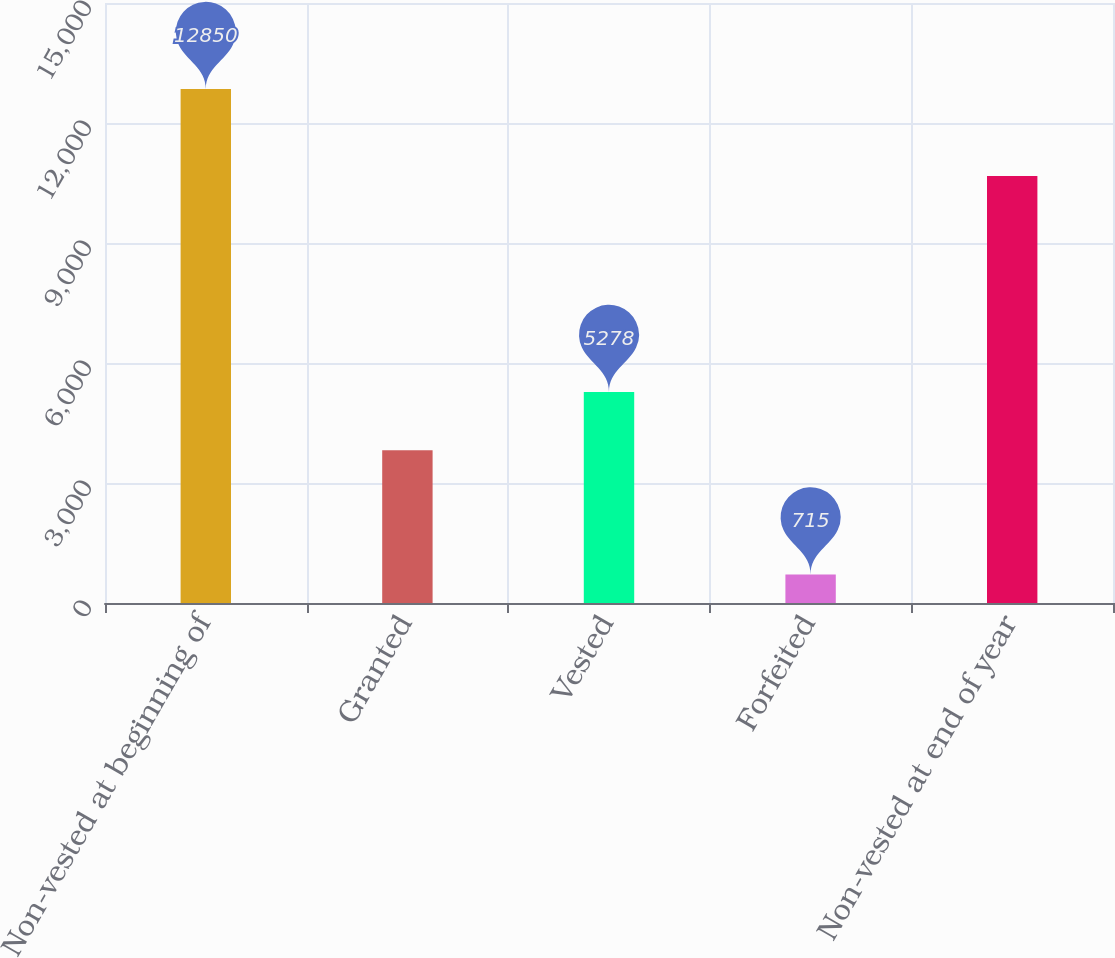Convert chart. <chart><loc_0><loc_0><loc_500><loc_500><bar_chart><fcel>Non-vested at beginning of<fcel>Granted<fcel>Vested<fcel>Forfeited<fcel>Non-vested at end of year<nl><fcel>12850<fcel>3817<fcel>5278<fcel>715<fcel>10674<nl></chart> 